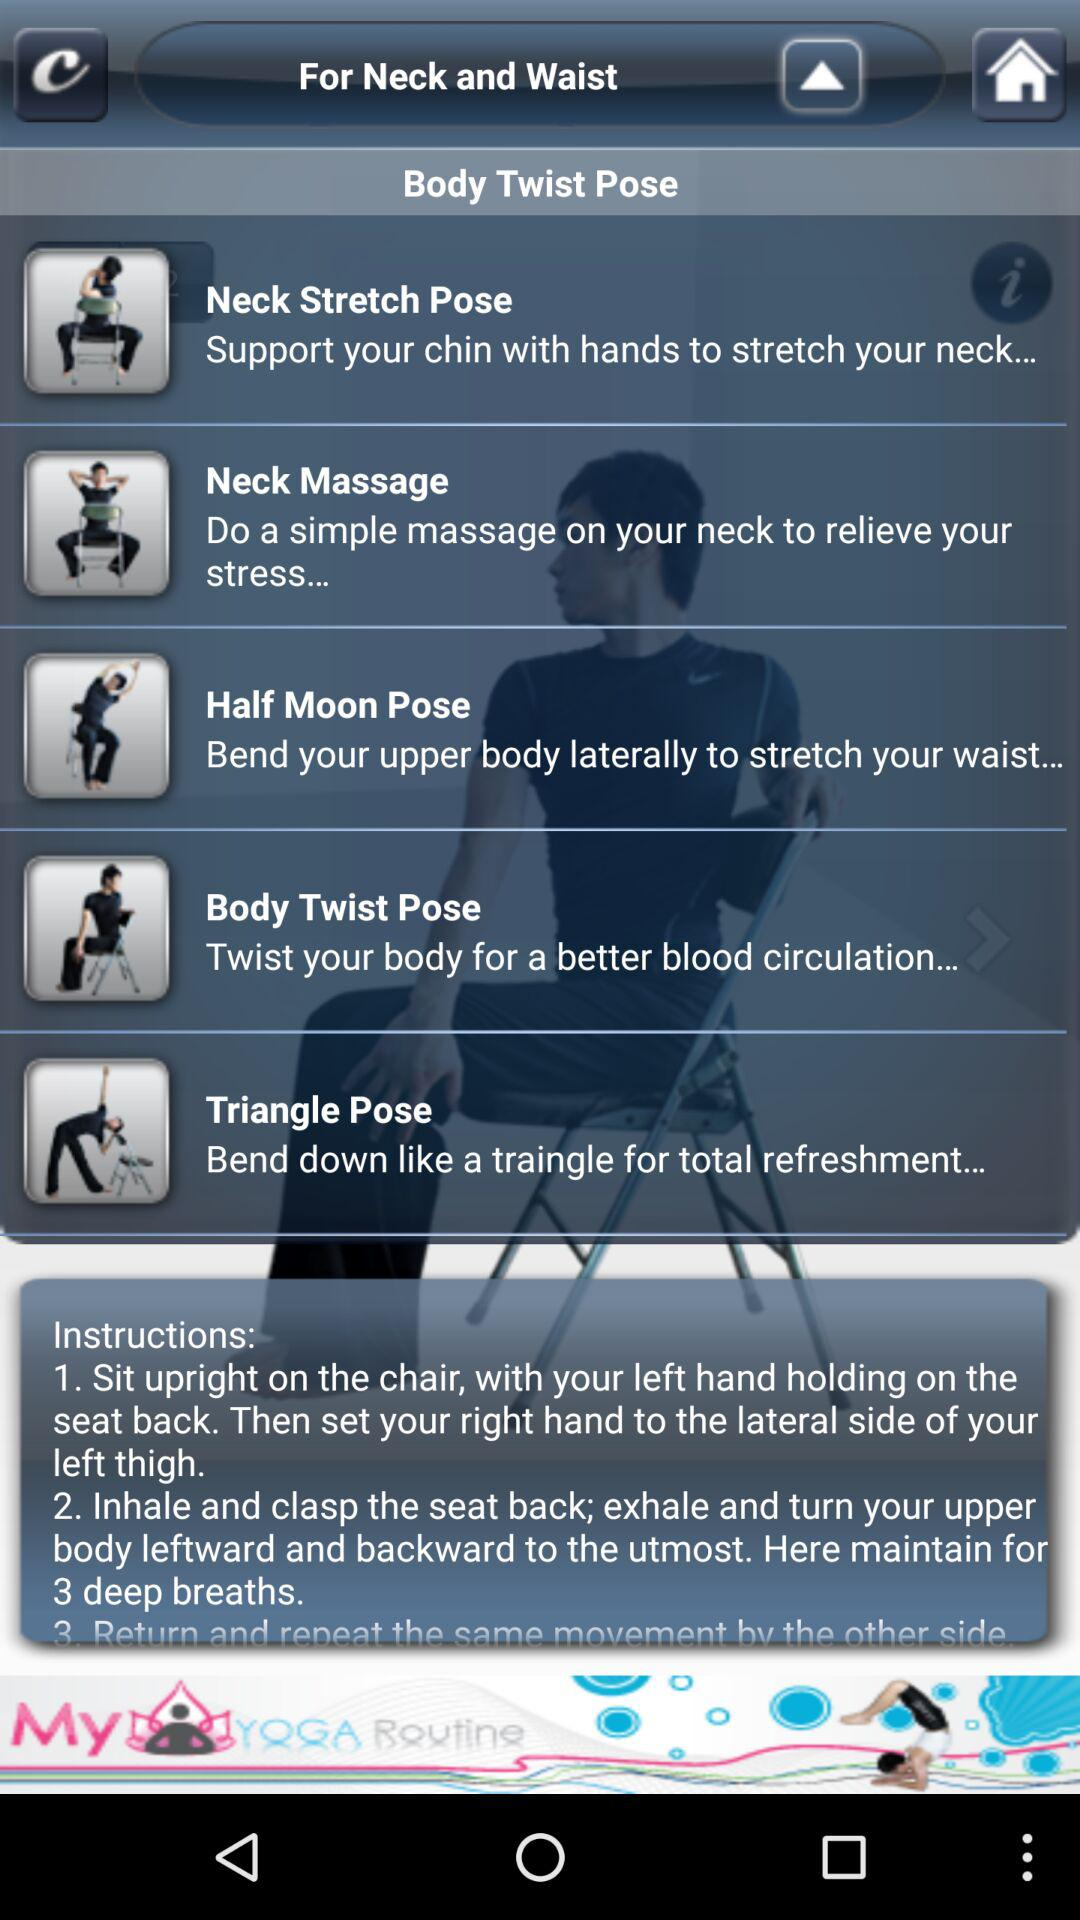What are the given instructions? The given instructions are "Sit upright on the chair, with your left hand holding on the seat back. Then set your right hand to the lateral side of your left thigh" and "Inhale and clasp the seat back; exhale and turn your upper body leftward and backward to the utmost. Here maintain for 3 deep breaths". 